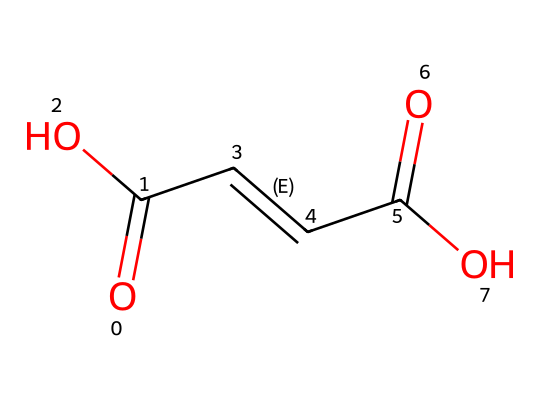What is the name of the geometrical isomers represented by this SMILES? The SMILES corresponds to maleic acid and fumaric acid, which are geometric isomers differing in the orientation of their double bonds.
Answer: maleic acid and fumaric acid How many double bonds are present in this compound? In the structure, there are two carbon-carbon double bonds indicated by the "=" signs in the SMILES representation.
Answer: 2 What functional groups are present in this chemical structure? The chemical contains two carboxylic acid functional groups (-COOH) as indicated by "C(=O)O" segments in the SMILES.
Answer: carboxylic acids What is the difference in configuration between fumaric and maleic acid? Fumaric acid has a trans configuration (opposite sides) while maleic acid has a cis configuration (same side) around its double bonds.
Answer: trans and cis What role do fumaric and maleic acid play as food additives? These acids act primarily as acidity regulators and preservatives in food products.
Answer: acidity regulators and preservatives Which isomer, maleic or fumaric acid, has a higher solubility in water? Maleic acid, with its cis configuration, has higher solubility in water compared to fumaric acid which is trans.
Answer: maleic acid What is the pKa value of maleic acid? Maleic acid has a pKa value of approximately 1.9 for its first dissociation, indicating its strength as an acid.
Answer: 1.9 